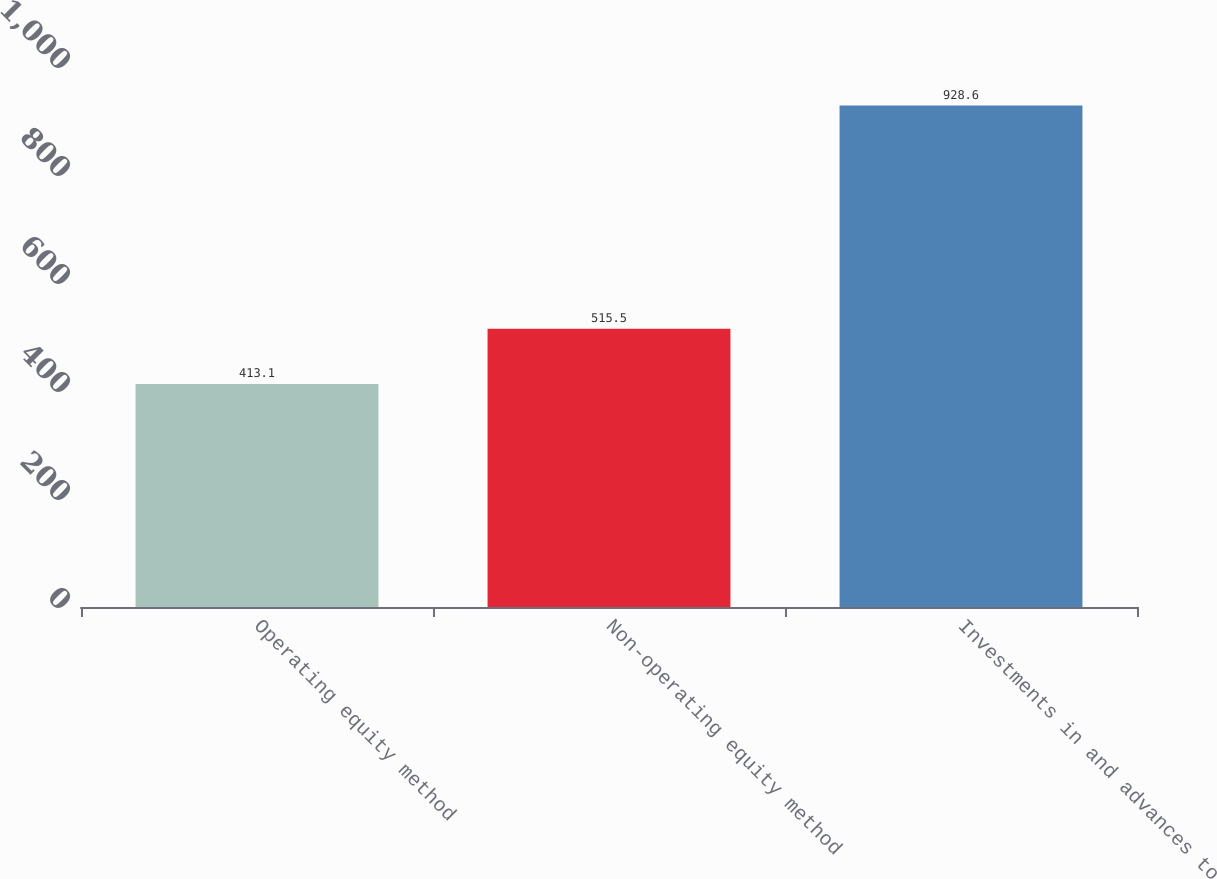<chart> <loc_0><loc_0><loc_500><loc_500><bar_chart><fcel>Operating equity method<fcel>Non-operating equity method<fcel>Investments in and advances to<nl><fcel>413.1<fcel>515.5<fcel>928.6<nl></chart> 